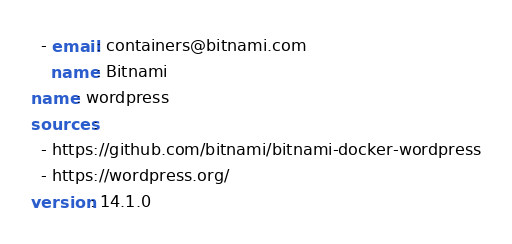Convert code to text. <code><loc_0><loc_0><loc_500><loc_500><_YAML_>  - email: containers@bitnami.com
    name: Bitnami
name: wordpress
sources:
  - https://github.com/bitnami/bitnami-docker-wordpress
  - https://wordpress.org/
version: 14.1.0
</code> 